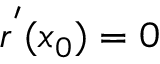Convert formula to latex. <formula><loc_0><loc_0><loc_500><loc_500>r ^ { ^ { \prime } } ( x _ { 0 } ) = 0</formula> 